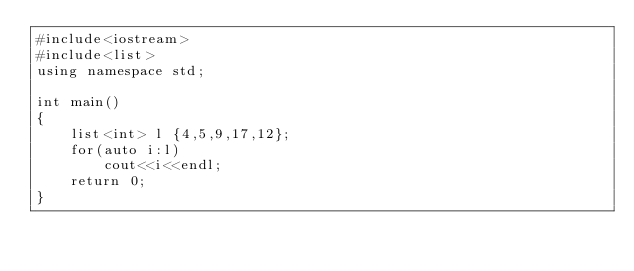<code> <loc_0><loc_0><loc_500><loc_500><_C++_>#include<iostream>
#include<list>
using namespace std;

int main()
{
    list<int> l {4,5,9,17,12};
    for(auto i:l)
        cout<<i<<endl;
    return 0;
}</code> 